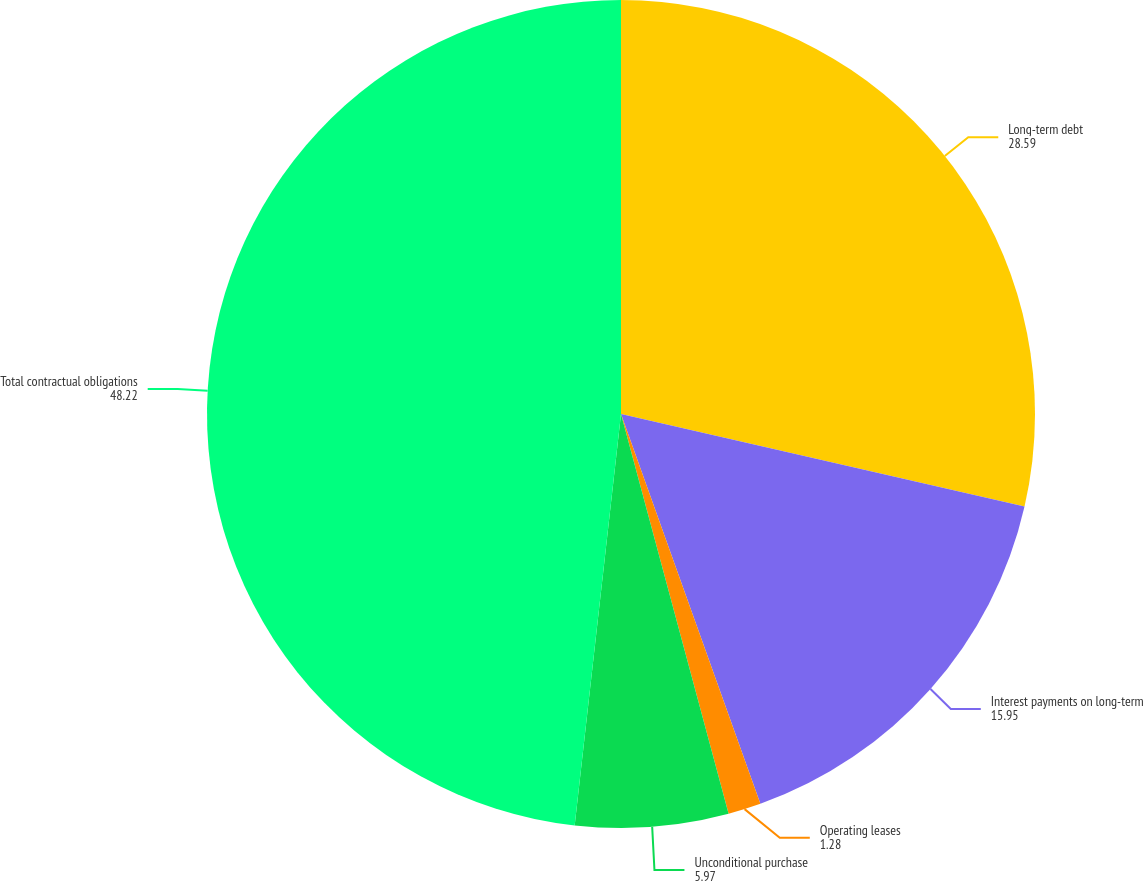<chart> <loc_0><loc_0><loc_500><loc_500><pie_chart><fcel>Long-term debt<fcel>Interest payments on long-term<fcel>Operating leases<fcel>Unconditional purchase<fcel>Total contractual obligations<nl><fcel>28.59%<fcel>15.95%<fcel>1.28%<fcel>5.97%<fcel>48.22%<nl></chart> 